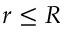Convert formula to latex. <formula><loc_0><loc_0><loc_500><loc_500>r \leq R</formula> 